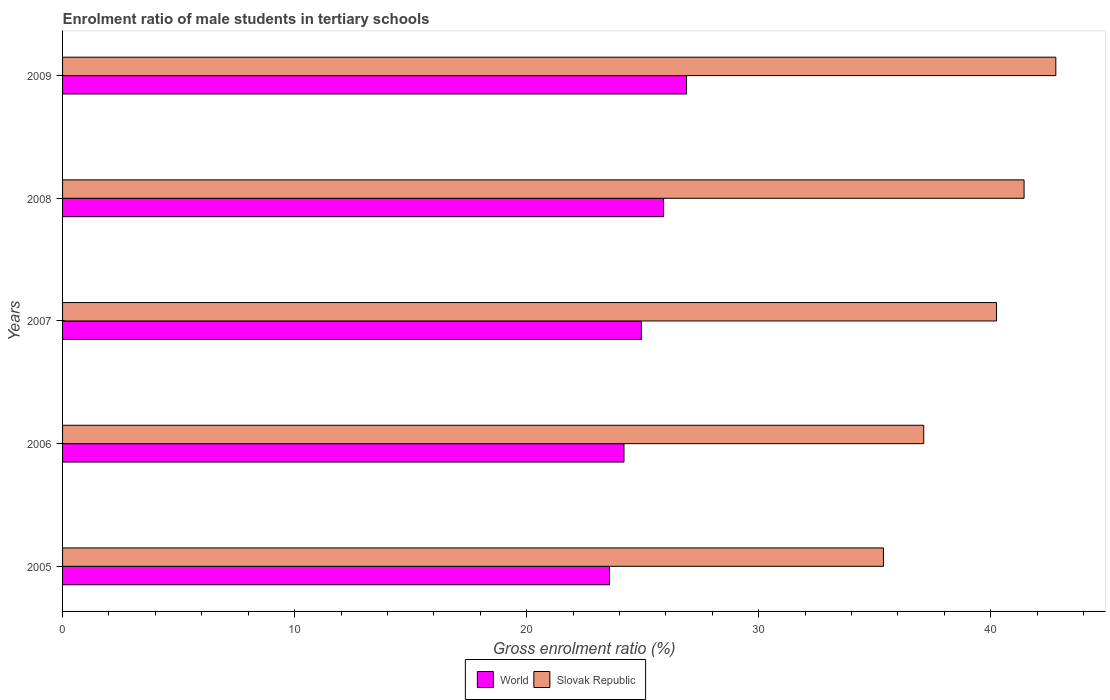How many different coloured bars are there?
Provide a short and direct response. 2. How many groups of bars are there?
Provide a short and direct response. 5. Are the number of bars per tick equal to the number of legend labels?
Your answer should be compact. Yes. Are the number of bars on each tick of the Y-axis equal?
Provide a succinct answer. Yes. How many bars are there on the 3rd tick from the top?
Provide a short and direct response. 2. How many bars are there on the 1st tick from the bottom?
Provide a succinct answer. 2. What is the enrolment ratio of male students in tertiary schools in World in 2008?
Your response must be concise. 25.9. Across all years, what is the maximum enrolment ratio of male students in tertiary schools in Slovak Republic?
Your response must be concise. 42.8. Across all years, what is the minimum enrolment ratio of male students in tertiary schools in World?
Your response must be concise. 23.57. In which year was the enrolment ratio of male students in tertiary schools in Slovak Republic minimum?
Keep it short and to the point. 2005. What is the total enrolment ratio of male students in tertiary schools in World in the graph?
Provide a succinct answer. 125.5. What is the difference between the enrolment ratio of male students in tertiary schools in Slovak Republic in 2005 and that in 2006?
Make the answer very short. -1.74. What is the difference between the enrolment ratio of male students in tertiary schools in Slovak Republic in 2006 and the enrolment ratio of male students in tertiary schools in World in 2007?
Offer a terse response. 12.17. What is the average enrolment ratio of male students in tertiary schools in World per year?
Offer a terse response. 25.1. In the year 2008, what is the difference between the enrolment ratio of male students in tertiary schools in World and enrolment ratio of male students in tertiary schools in Slovak Republic?
Your response must be concise. -15.54. What is the ratio of the enrolment ratio of male students in tertiary schools in World in 2005 to that in 2009?
Your response must be concise. 0.88. Is the enrolment ratio of male students in tertiary schools in World in 2005 less than that in 2008?
Provide a succinct answer. Yes. What is the difference between the highest and the second highest enrolment ratio of male students in tertiary schools in Slovak Republic?
Ensure brevity in your answer.  1.37. What is the difference between the highest and the lowest enrolment ratio of male students in tertiary schools in Slovak Republic?
Ensure brevity in your answer.  7.43. In how many years, is the enrolment ratio of male students in tertiary schools in World greater than the average enrolment ratio of male students in tertiary schools in World taken over all years?
Your answer should be compact. 2. What does the 1st bar from the top in 2009 represents?
Your answer should be compact. Slovak Republic. What does the 2nd bar from the bottom in 2008 represents?
Offer a terse response. Slovak Republic. Are all the bars in the graph horizontal?
Keep it short and to the point. Yes. What is the difference between two consecutive major ticks on the X-axis?
Provide a succinct answer. 10. Does the graph contain any zero values?
Give a very brief answer. No. Does the graph contain grids?
Offer a terse response. No. How many legend labels are there?
Provide a succinct answer. 2. What is the title of the graph?
Make the answer very short. Enrolment ratio of male students in tertiary schools. What is the Gross enrolment ratio (%) of World in 2005?
Ensure brevity in your answer.  23.57. What is the Gross enrolment ratio (%) in Slovak Republic in 2005?
Make the answer very short. 35.38. What is the Gross enrolment ratio (%) in World in 2006?
Ensure brevity in your answer.  24.19. What is the Gross enrolment ratio (%) of Slovak Republic in 2006?
Provide a short and direct response. 37.11. What is the Gross enrolment ratio (%) in World in 2007?
Ensure brevity in your answer.  24.94. What is the Gross enrolment ratio (%) of Slovak Republic in 2007?
Provide a short and direct response. 40.25. What is the Gross enrolment ratio (%) in World in 2008?
Your answer should be compact. 25.9. What is the Gross enrolment ratio (%) in Slovak Republic in 2008?
Give a very brief answer. 41.44. What is the Gross enrolment ratio (%) in World in 2009?
Give a very brief answer. 26.89. What is the Gross enrolment ratio (%) of Slovak Republic in 2009?
Provide a succinct answer. 42.8. Across all years, what is the maximum Gross enrolment ratio (%) in World?
Ensure brevity in your answer.  26.89. Across all years, what is the maximum Gross enrolment ratio (%) of Slovak Republic?
Make the answer very short. 42.8. Across all years, what is the minimum Gross enrolment ratio (%) of World?
Offer a terse response. 23.57. Across all years, what is the minimum Gross enrolment ratio (%) in Slovak Republic?
Offer a very short reply. 35.38. What is the total Gross enrolment ratio (%) in World in the graph?
Provide a succinct answer. 125.5. What is the total Gross enrolment ratio (%) of Slovak Republic in the graph?
Give a very brief answer. 196.98. What is the difference between the Gross enrolment ratio (%) in World in 2005 and that in 2006?
Keep it short and to the point. -0.62. What is the difference between the Gross enrolment ratio (%) of Slovak Republic in 2005 and that in 2006?
Make the answer very short. -1.74. What is the difference between the Gross enrolment ratio (%) in World in 2005 and that in 2007?
Provide a succinct answer. -1.37. What is the difference between the Gross enrolment ratio (%) in Slovak Republic in 2005 and that in 2007?
Your answer should be compact. -4.87. What is the difference between the Gross enrolment ratio (%) of World in 2005 and that in 2008?
Offer a terse response. -2.33. What is the difference between the Gross enrolment ratio (%) of Slovak Republic in 2005 and that in 2008?
Your answer should be compact. -6.06. What is the difference between the Gross enrolment ratio (%) of World in 2005 and that in 2009?
Keep it short and to the point. -3.32. What is the difference between the Gross enrolment ratio (%) of Slovak Republic in 2005 and that in 2009?
Offer a very short reply. -7.43. What is the difference between the Gross enrolment ratio (%) of World in 2006 and that in 2007?
Your answer should be compact. -0.75. What is the difference between the Gross enrolment ratio (%) in Slovak Republic in 2006 and that in 2007?
Your answer should be very brief. -3.14. What is the difference between the Gross enrolment ratio (%) of World in 2006 and that in 2008?
Provide a short and direct response. -1.71. What is the difference between the Gross enrolment ratio (%) in Slovak Republic in 2006 and that in 2008?
Ensure brevity in your answer.  -4.32. What is the difference between the Gross enrolment ratio (%) in World in 2006 and that in 2009?
Your answer should be very brief. -2.7. What is the difference between the Gross enrolment ratio (%) of Slovak Republic in 2006 and that in 2009?
Provide a succinct answer. -5.69. What is the difference between the Gross enrolment ratio (%) of World in 2007 and that in 2008?
Give a very brief answer. -0.96. What is the difference between the Gross enrolment ratio (%) in Slovak Republic in 2007 and that in 2008?
Your answer should be very brief. -1.19. What is the difference between the Gross enrolment ratio (%) in World in 2007 and that in 2009?
Provide a succinct answer. -1.95. What is the difference between the Gross enrolment ratio (%) of Slovak Republic in 2007 and that in 2009?
Keep it short and to the point. -2.55. What is the difference between the Gross enrolment ratio (%) of World in 2008 and that in 2009?
Ensure brevity in your answer.  -0.99. What is the difference between the Gross enrolment ratio (%) in Slovak Republic in 2008 and that in 2009?
Provide a succinct answer. -1.37. What is the difference between the Gross enrolment ratio (%) in World in 2005 and the Gross enrolment ratio (%) in Slovak Republic in 2006?
Ensure brevity in your answer.  -13.54. What is the difference between the Gross enrolment ratio (%) of World in 2005 and the Gross enrolment ratio (%) of Slovak Republic in 2007?
Your answer should be compact. -16.68. What is the difference between the Gross enrolment ratio (%) of World in 2005 and the Gross enrolment ratio (%) of Slovak Republic in 2008?
Offer a very short reply. -17.87. What is the difference between the Gross enrolment ratio (%) in World in 2005 and the Gross enrolment ratio (%) in Slovak Republic in 2009?
Your response must be concise. -19.23. What is the difference between the Gross enrolment ratio (%) of World in 2006 and the Gross enrolment ratio (%) of Slovak Republic in 2007?
Keep it short and to the point. -16.06. What is the difference between the Gross enrolment ratio (%) of World in 2006 and the Gross enrolment ratio (%) of Slovak Republic in 2008?
Your answer should be compact. -17.24. What is the difference between the Gross enrolment ratio (%) of World in 2006 and the Gross enrolment ratio (%) of Slovak Republic in 2009?
Your answer should be compact. -18.61. What is the difference between the Gross enrolment ratio (%) of World in 2007 and the Gross enrolment ratio (%) of Slovak Republic in 2008?
Offer a terse response. -16.49. What is the difference between the Gross enrolment ratio (%) in World in 2007 and the Gross enrolment ratio (%) in Slovak Republic in 2009?
Provide a short and direct response. -17.86. What is the difference between the Gross enrolment ratio (%) in World in 2008 and the Gross enrolment ratio (%) in Slovak Republic in 2009?
Offer a very short reply. -16.9. What is the average Gross enrolment ratio (%) of World per year?
Offer a terse response. 25.1. What is the average Gross enrolment ratio (%) of Slovak Republic per year?
Your response must be concise. 39.4. In the year 2005, what is the difference between the Gross enrolment ratio (%) of World and Gross enrolment ratio (%) of Slovak Republic?
Offer a very short reply. -11.81. In the year 2006, what is the difference between the Gross enrolment ratio (%) in World and Gross enrolment ratio (%) in Slovak Republic?
Your answer should be compact. -12.92. In the year 2007, what is the difference between the Gross enrolment ratio (%) in World and Gross enrolment ratio (%) in Slovak Republic?
Ensure brevity in your answer.  -15.31. In the year 2008, what is the difference between the Gross enrolment ratio (%) in World and Gross enrolment ratio (%) in Slovak Republic?
Your answer should be very brief. -15.54. In the year 2009, what is the difference between the Gross enrolment ratio (%) in World and Gross enrolment ratio (%) in Slovak Republic?
Make the answer very short. -15.91. What is the ratio of the Gross enrolment ratio (%) in World in 2005 to that in 2006?
Provide a short and direct response. 0.97. What is the ratio of the Gross enrolment ratio (%) of Slovak Republic in 2005 to that in 2006?
Offer a terse response. 0.95. What is the ratio of the Gross enrolment ratio (%) of World in 2005 to that in 2007?
Provide a succinct answer. 0.94. What is the ratio of the Gross enrolment ratio (%) of Slovak Republic in 2005 to that in 2007?
Provide a succinct answer. 0.88. What is the ratio of the Gross enrolment ratio (%) in World in 2005 to that in 2008?
Make the answer very short. 0.91. What is the ratio of the Gross enrolment ratio (%) in Slovak Republic in 2005 to that in 2008?
Your response must be concise. 0.85. What is the ratio of the Gross enrolment ratio (%) of World in 2005 to that in 2009?
Provide a succinct answer. 0.88. What is the ratio of the Gross enrolment ratio (%) of Slovak Republic in 2005 to that in 2009?
Your response must be concise. 0.83. What is the ratio of the Gross enrolment ratio (%) of Slovak Republic in 2006 to that in 2007?
Ensure brevity in your answer.  0.92. What is the ratio of the Gross enrolment ratio (%) of World in 2006 to that in 2008?
Make the answer very short. 0.93. What is the ratio of the Gross enrolment ratio (%) in Slovak Republic in 2006 to that in 2008?
Provide a succinct answer. 0.9. What is the ratio of the Gross enrolment ratio (%) of World in 2006 to that in 2009?
Provide a succinct answer. 0.9. What is the ratio of the Gross enrolment ratio (%) of Slovak Republic in 2006 to that in 2009?
Keep it short and to the point. 0.87. What is the ratio of the Gross enrolment ratio (%) of World in 2007 to that in 2008?
Your answer should be compact. 0.96. What is the ratio of the Gross enrolment ratio (%) of Slovak Republic in 2007 to that in 2008?
Your response must be concise. 0.97. What is the ratio of the Gross enrolment ratio (%) of World in 2007 to that in 2009?
Make the answer very short. 0.93. What is the ratio of the Gross enrolment ratio (%) of Slovak Republic in 2007 to that in 2009?
Offer a very short reply. 0.94. What is the ratio of the Gross enrolment ratio (%) in World in 2008 to that in 2009?
Provide a short and direct response. 0.96. What is the ratio of the Gross enrolment ratio (%) in Slovak Republic in 2008 to that in 2009?
Your answer should be very brief. 0.97. What is the difference between the highest and the second highest Gross enrolment ratio (%) of Slovak Republic?
Ensure brevity in your answer.  1.37. What is the difference between the highest and the lowest Gross enrolment ratio (%) of World?
Provide a succinct answer. 3.32. What is the difference between the highest and the lowest Gross enrolment ratio (%) of Slovak Republic?
Your response must be concise. 7.43. 